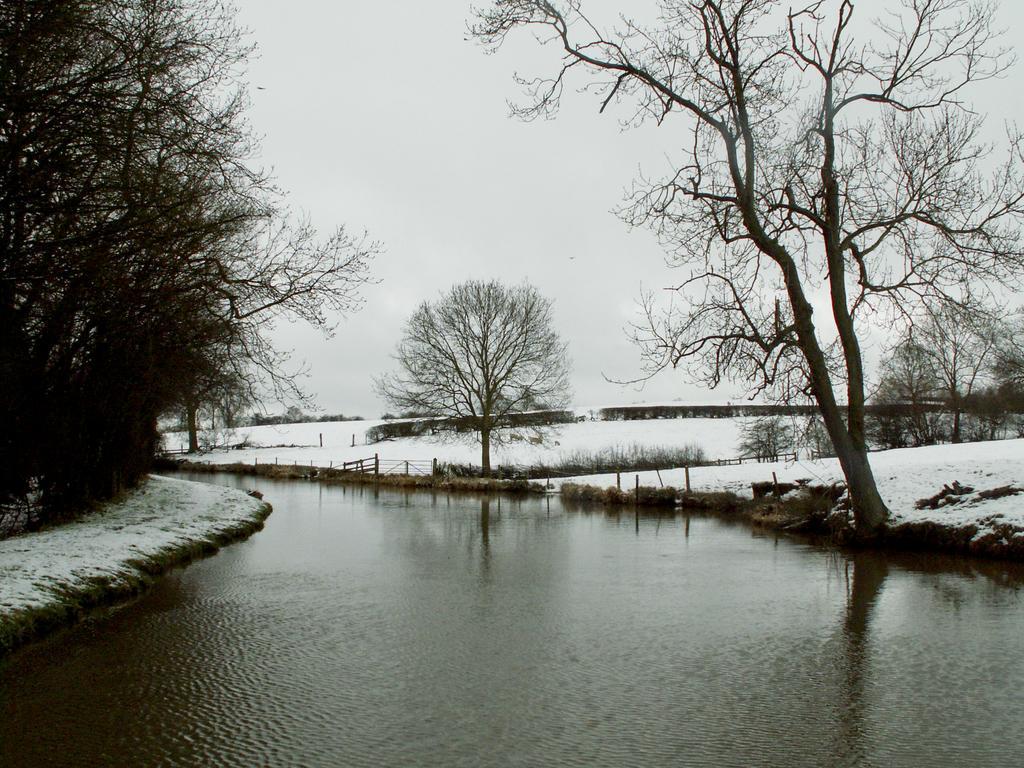In one or two sentences, can you explain what this image depicts? This is an outside view. At the bottom there is a river. In the background there are some trees. On the ground, I can see the snow. At the top of the image I can see the sky. 